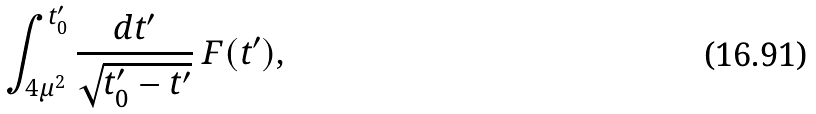Convert formula to latex. <formula><loc_0><loc_0><loc_500><loc_500>\int _ { 4 \mu ^ { 2 } } ^ { t ^ { \prime } _ { 0 } } \frac { d t ^ { \prime } } { \sqrt { t ^ { \prime } _ { 0 } - t ^ { \prime } } } \ F ( t ^ { \prime } ) ,</formula> 